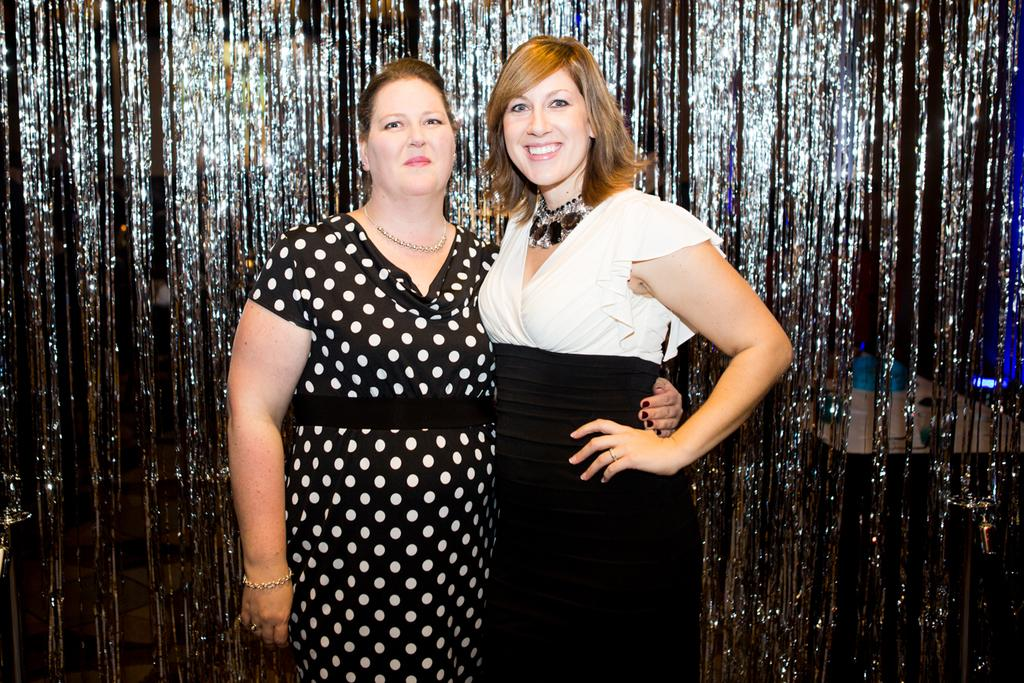How many people are in the image? There are two women in the picture. Where are the women positioned in the image? The women are standing in the middle of the picture. What expression do the women have? Both women are smiling. What colors are the women's dresses? The women are wearing black and white color dresses. What type of pipe can be seen in the hands of one of the women? There is no pipe present in the image; both women are shown with empty hands. 